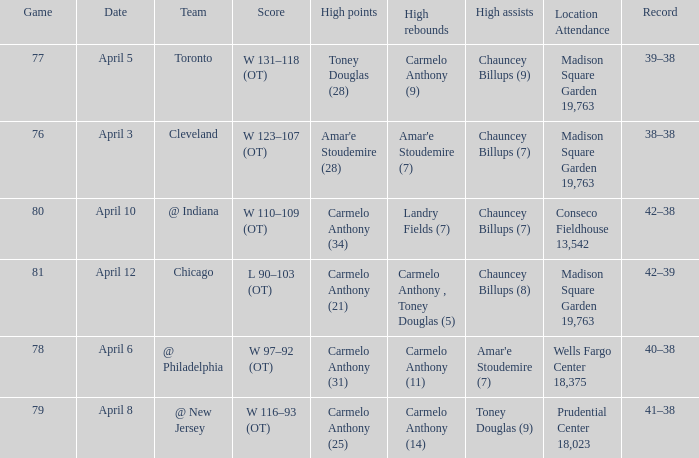Can you parse all the data within this table? {'header': ['Game', 'Date', 'Team', 'Score', 'High points', 'High rebounds', 'High assists', 'Location Attendance', 'Record'], 'rows': [['77', 'April 5', 'Toronto', 'W 131–118 (OT)', 'Toney Douglas (28)', 'Carmelo Anthony (9)', 'Chauncey Billups (9)', 'Madison Square Garden 19,763', '39–38'], ['76', 'April 3', 'Cleveland', 'W 123–107 (OT)', "Amar'e Stoudemire (28)", "Amar'e Stoudemire (7)", 'Chauncey Billups (7)', 'Madison Square Garden 19,763', '38–38'], ['80', 'April 10', '@ Indiana', 'W 110–109 (OT)', 'Carmelo Anthony (34)', 'Landry Fields (7)', 'Chauncey Billups (7)', 'Conseco Fieldhouse 13,542', '42–38'], ['81', 'April 12', 'Chicago', 'L 90–103 (OT)', 'Carmelo Anthony (21)', 'Carmelo Anthony , Toney Douglas (5)', 'Chauncey Billups (8)', 'Madison Square Garden 19,763', '42–39'], ['78', 'April 6', '@ Philadelphia', 'W 97–92 (OT)', 'Carmelo Anthony (31)', 'Carmelo Anthony (11)', "Amar'e Stoudemire (7)", 'Wells Fargo Center 18,375', '40–38'], ['79', 'April 8', '@ New Jersey', 'W 116–93 (OT)', 'Carmelo Anthony (25)', 'Carmelo Anthony (14)', 'Toney Douglas (9)', 'Prudential Center 18,023', '41–38']]} Name the date for cleveland April 3. 